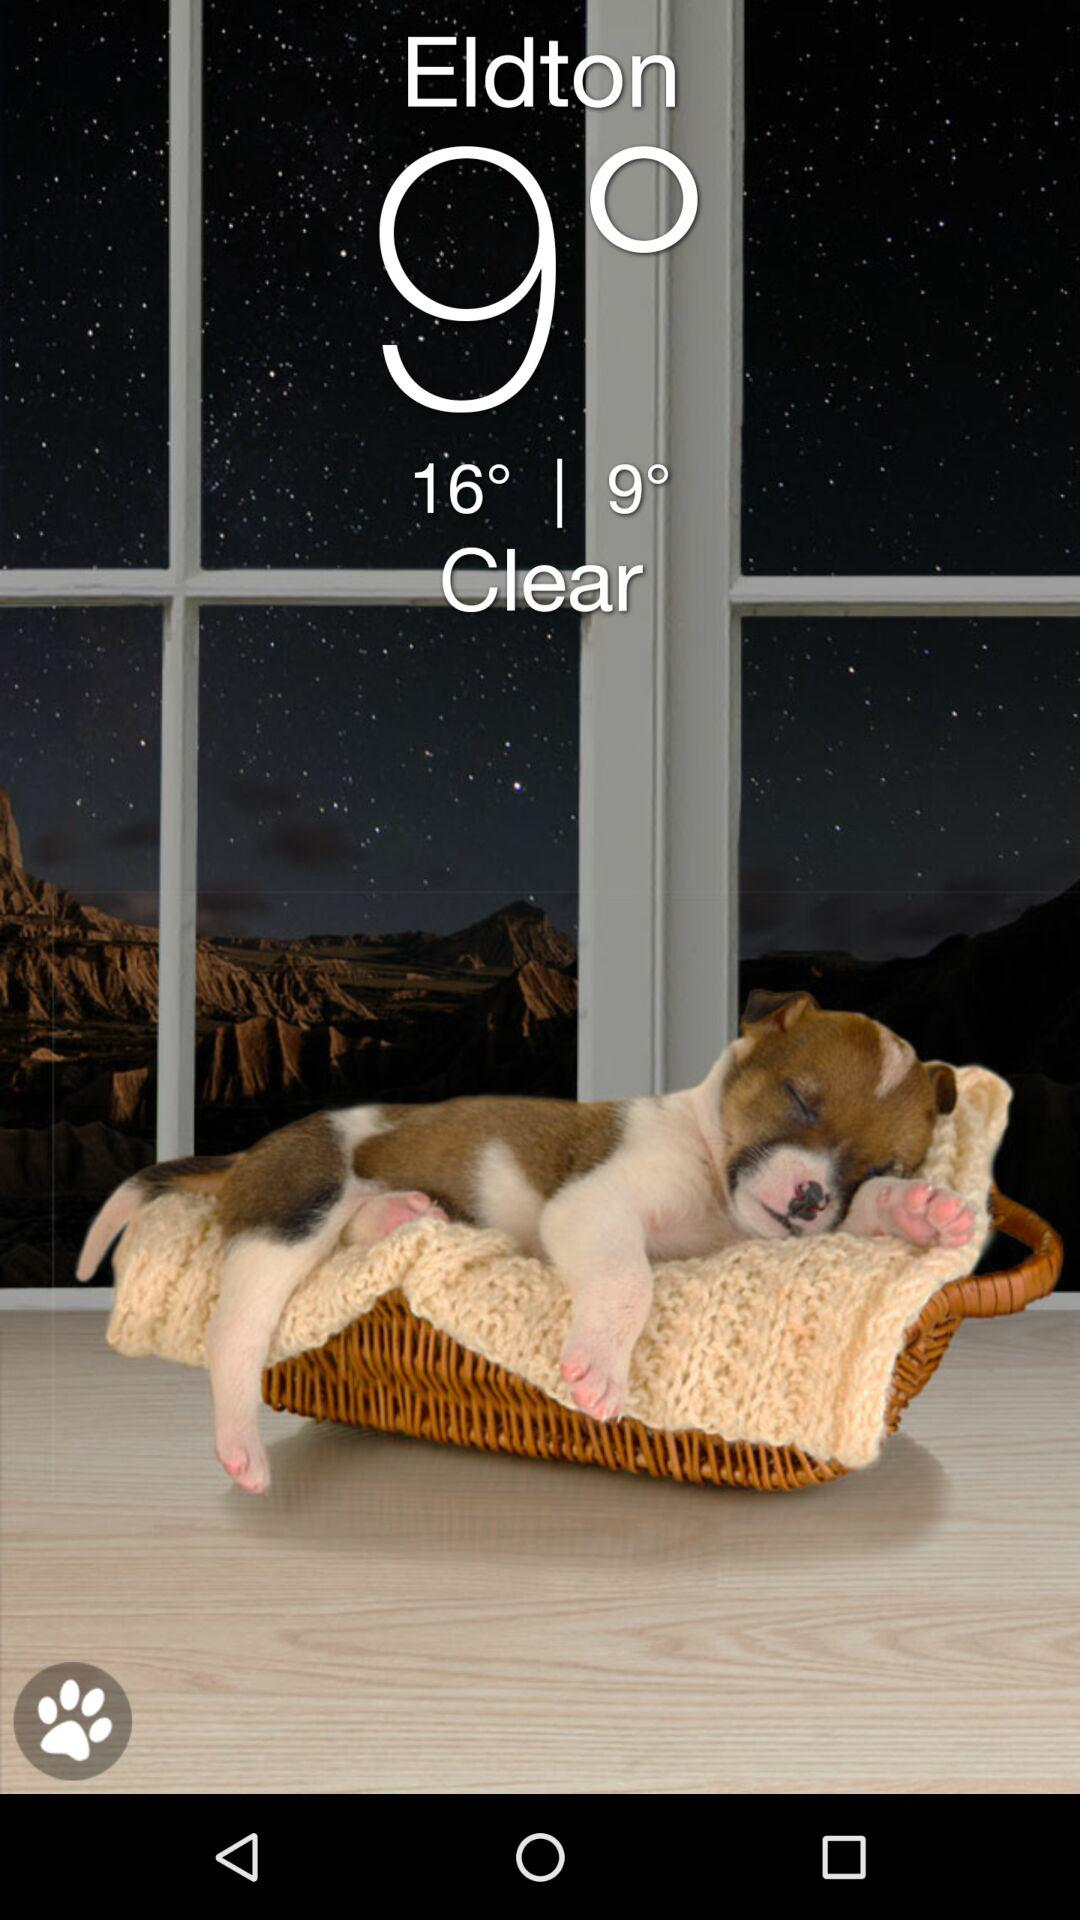What is the temperature? The temperature is 9°. 